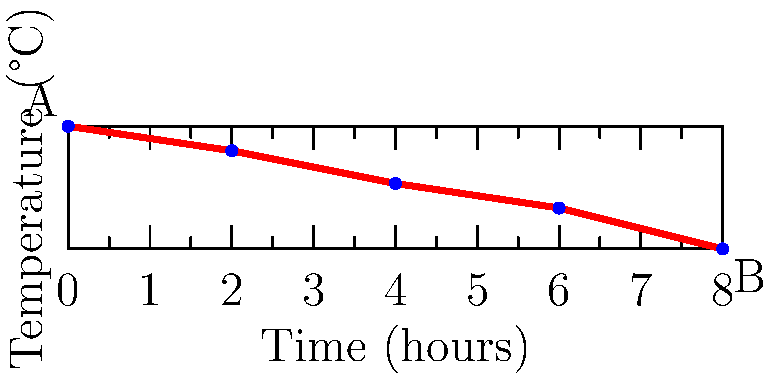The graph shows the temperature readings of a recovering patient over an 8-hour period. Point A represents the initial temperature reading, and point B represents the final reading. Calculate the slope of the line AB, which represents the average rate of temperature change per hour. Round your answer to three decimal places. To find the slope of the line AB, we'll use the slope formula:

$$ \text{Slope} = \frac{y_2 - y_1}{x_2 - x_1} $$

Where $(x_1, y_1)$ is the coordinate of point A and $(x_2, y_2)$ is the coordinate of point B.

Step 1: Identify the coordinates
- Point A: $(0, 38.5)$
- Point B: $(8, 37.0)$

Step 2: Plug the values into the slope formula
$$ \text{Slope} = \frac{37.0 - 38.5}{8 - 0} = \frac{-1.5}{8} $$

Step 3: Perform the division
$$ \text{Slope} = -0.1875 $$

Step 4: Round to three decimal places
$$ \text{Slope} \approx -0.188 $$

The negative slope indicates that the temperature is decreasing over time, which is expected for a recovering patient.
Answer: $-0.188$ °C/hour 